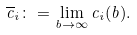<formula> <loc_0><loc_0><loc_500><loc_500>\overline { c } _ { i } \colon = \lim _ { b \to \infty } c _ { i } ( b ) .</formula> 